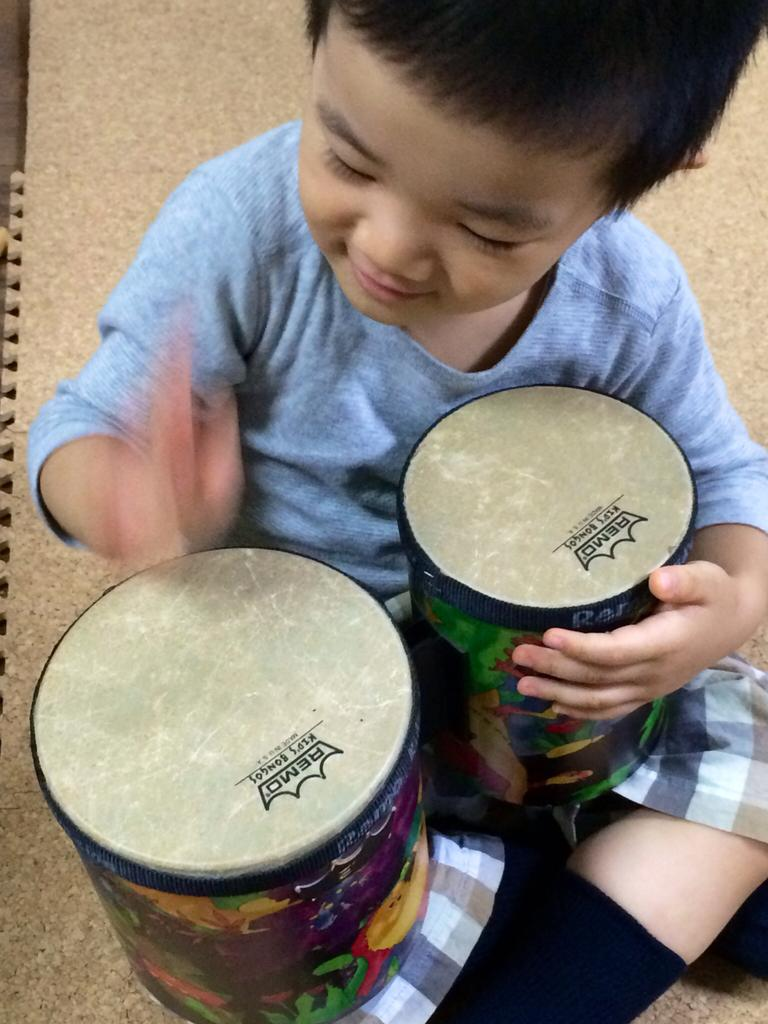What is the main subject of the image? There is a person in the image. What is the person doing in the image? The person is sitting and playing musical instruments. What surface can be seen beneath the person? There is a floor visible in the image. Can you tell me how many dogs are present in the image? There are no dogs present in the image; it features a person playing musical instruments. What is the value of the wilderness in the image? There is no wilderness present in the image, so it is not possible to determine its value. 